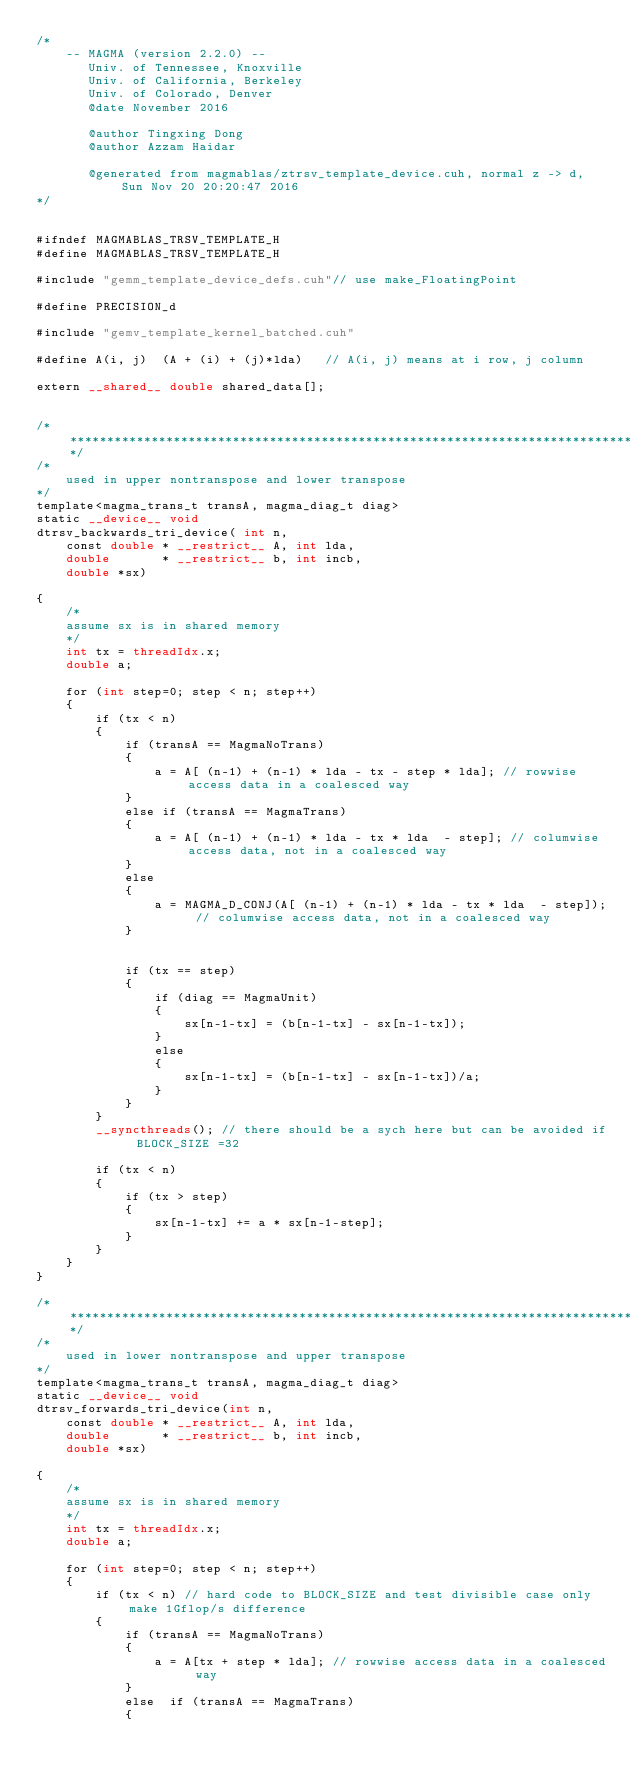Convert code to text. <code><loc_0><loc_0><loc_500><loc_500><_Cuda_>/*
    -- MAGMA (version 2.2.0) --
       Univ. of Tennessee, Knoxville
       Univ. of California, Berkeley
       Univ. of Colorado, Denver
       @date November 2016

       @author Tingxing Dong
       @author Azzam Haidar

       @generated from magmablas/ztrsv_template_device.cuh, normal z -> d, Sun Nov 20 20:20:47 2016
*/


#ifndef MAGMABLAS_TRSV_TEMPLATE_H
#define MAGMABLAS_TRSV_TEMPLATE_H

#include "gemm_template_device_defs.cuh"// use make_FloatingPoint

#define PRECISION_d

#include "gemv_template_kernel_batched.cuh"

#define A(i, j)  (A + (i) + (j)*lda)   // A(i, j) means at i row, j column

extern __shared__ double shared_data[];


/******************************************************************************/
/*
    used in upper nontranspose and lower transpose
*/
template<magma_trans_t transA, magma_diag_t diag>
static __device__ void
dtrsv_backwards_tri_device( int n,
    const double * __restrict__ A, int lda,
    double       * __restrict__ b, int incb,
    double *sx)

{
    /*
    assume sx is in shared memory
    */
    int tx = threadIdx.x;
    double a;

    for (int step=0; step < n; step++)
    {
        if (tx < n)
        {
            if (transA == MagmaNoTrans)
            {
                a = A[ (n-1) + (n-1) * lda - tx - step * lda]; // rowwise access data in a coalesced way
            }
            else if (transA == MagmaTrans)
            {
                a = A[ (n-1) + (n-1) * lda - tx * lda  - step]; // columwise access data, not in a coalesced way
            }
            else
            {
                a = MAGMA_D_CONJ(A[ (n-1) + (n-1) * lda - tx * lda  - step]); // columwise access data, not in a coalesced way
            }


            if (tx == step)
            {
                if (diag == MagmaUnit)
                {
                    sx[n-1-tx] = (b[n-1-tx] - sx[n-1-tx]);
                }
                else
                {
                    sx[n-1-tx] = (b[n-1-tx] - sx[n-1-tx])/a;
                }
            }
        }
        __syncthreads(); // there should be a sych here but can be avoided if BLOCK_SIZE =32

        if (tx < n)
        {
            if (tx > step)
            {
                sx[n-1-tx] += a * sx[n-1-step];
            }
        }
    }
}

/******************************************************************************/
/*
    used in lower nontranspose and upper transpose
*/
template<magma_trans_t transA, magma_diag_t diag>
static __device__ void
dtrsv_forwards_tri_device(int n,
    const double * __restrict__ A, int lda,
    double       * __restrict__ b, int incb,
    double *sx)

{
    /*
    assume sx is in shared memory
    */
    int tx = threadIdx.x;
    double a;

    for (int step=0; step < n; step++)
    {
        if (tx < n) // hard code to BLOCK_SIZE and test divisible case only make 1Gflop/s difference
        {
            if (transA == MagmaNoTrans)
            {
                a = A[tx + step * lda]; // rowwise access data in a coalesced way
            }
            else  if (transA == MagmaTrans)
            {</code> 